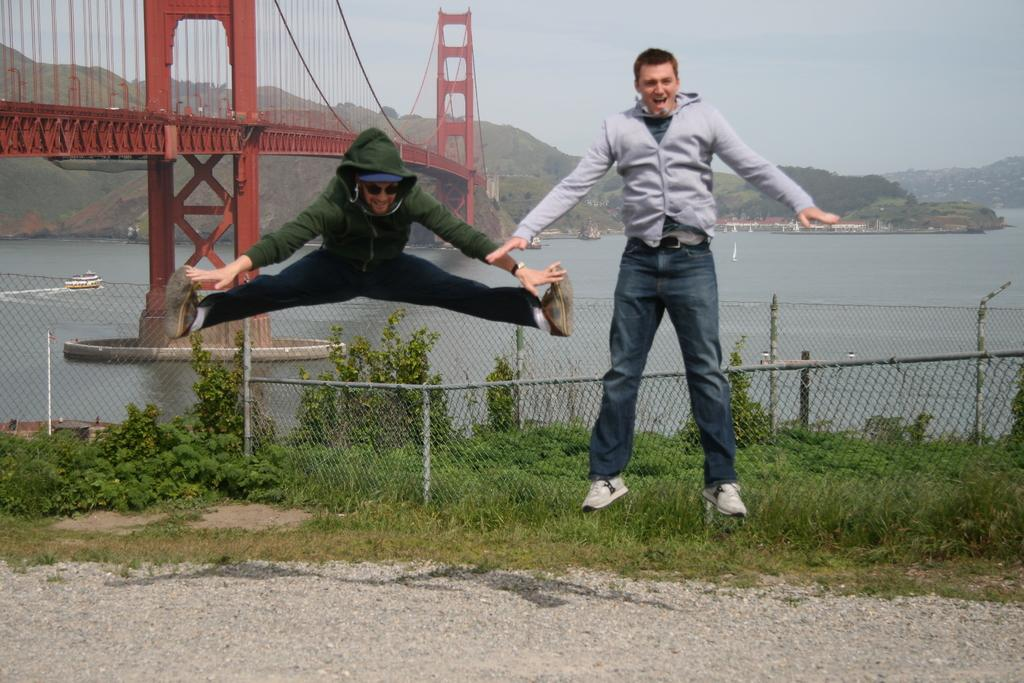What is happening on the left side of the image? There is a man jumping on the left side of the image, and he is wearing a green color sweater. What is happening on the right side of the image? There is another man jumping on the right side of the image, and he is wearing an ash color sweater. What can be seen in the background on the left side of the image? There is an iron bridge on the left side of the image. What type of fruit is hanging from the iron bridge in the image? There is no fruit hanging from the iron bridge in the image. How many sisters are present in the image? There is no mention of sisters in the image; it features two men jumping. 